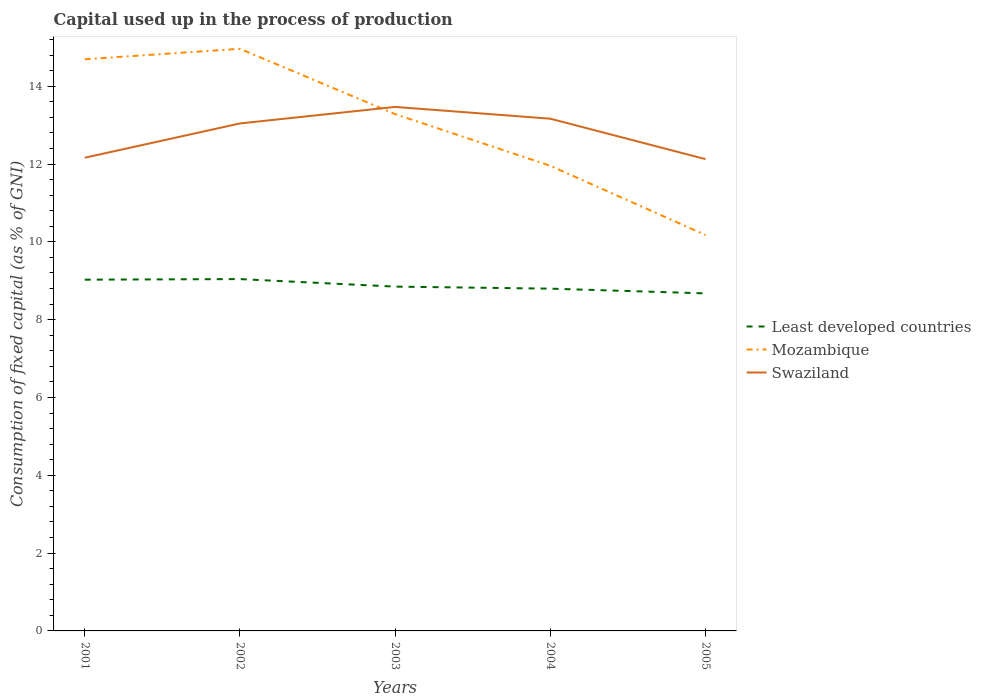Is the number of lines equal to the number of legend labels?
Make the answer very short. Yes. Across all years, what is the maximum capital used up in the process of production in Swaziland?
Keep it short and to the point. 12.13. What is the total capital used up in the process of production in Mozambique in the graph?
Make the answer very short. 1.33. What is the difference between the highest and the second highest capital used up in the process of production in Swaziland?
Offer a terse response. 1.34. What is the difference between the highest and the lowest capital used up in the process of production in Mozambique?
Ensure brevity in your answer.  3. How many lines are there?
Offer a very short reply. 3. How many years are there in the graph?
Your response must be concise. 5. What is the difference between two consecutive major ticks on the Y-axis?
Keep it short and to the point. 2. Are the values on the major ticks of Y-axis written in scientific E-notation?
Your response must be concise. No. Does the graph contain any zero values?
Keep it short and to the point. No. How many legend labels are there?
Give a very brief answer. 3. What is the title of the graph?
Keep it short and to the point. Capital used up in the process of production. What is the label or title of the X-axis?
Offer a very short reply. Years. What is the label or title of the Y-axis?
Offer a terse response. Consumption of fixed capital (as % of GNI). What is the Consumption of fixed capital (as % of GNI) of Least developed countries in 2001?
Your answer should be compact. 9.03. What is the Consumption of fixed capital (as % of GNI) in Mozambique in 2001?
Make the answer very short. 14.69. What is the Consumption of fixed capital (as % of GNI) in Swaziland in 2001?
Keep it short and to the point. 12.16. What is the Consumption of fixed capital (as % of GNI) in Least developed countries in 2002?
Give a very brief answer. 9.04. What is the Consumption of fixed capital (as % of GNI) in Mozambique in 2002?
Make the answer very short. 14.96. What is the Consumption of fixed capital (as % of GNI) in Swaziland in 2002?
Offer a terse response. 13.04. What is the Consumption of fixed capital (as % of GNI) of Least developed countries in 2003?
Offer a terse response. 8.85. What is the Consumption of fixed capital (as % of GNI) of Mozambique in 2003?
Ensure brevity in your answer.  13.28. What is the Consumption of fixed capital (as % of GNI) of Swaziland in 2003?
Your answer should be very brief. 13.47. What is the Consumption of fixed capital (as % of GNI) in Least developed countries in 2004?
Keep it short and to the point. 8.8. What is the Consumption of fixed capital (as % of GNI) of Mozambique in 2004?
Make the answer very short. 11.95. What is the Consumption of fixed capital (as % of GNI) of Swaziland in 2004?
Your answer should be compact. 13.16. What is the Consumption of fixed capital (as % of GNI) of Least developed countries in 2005?
Offer a very short reply. 8.68. What is the Consumption of fixed capital (as % of GNI) in Mozambique in 2005?
Offer a very short reply. 10.17. What is the Consumption of fixed capital (as % of GNI) in Swaziland in 2005?
Provide a succinct answer. 12.13. Across all years, what is the maximum Consumption of fixed capital (as % of GNI) in Least developed countries?
Make the answer very short. 9.04. Across all years, what is the maximum Consumption of fixed capital (as % of GNI) of Mozambique?
Provide a succinct answer. 14.96. Across all years, what is the maximum Consumption of fixed capital (as % of GNI) in Swaziland?
Offer a very short reply. 13.47. Across all years, what is the minimum Consumption of fixed capital (as % of GNI) in Least developed countries?
Keep it short and to the point. 8.68. Across all years, what is the minimum Consumption of fixed capital (as % of GNI) of Mozambique?
Offer a terse response. 10.17. Across all years, what is the minimum Consumption of fixed capital (as % of GNI) in Swaziland?
Keep it short and to the point. 12.13. What is the total Consumption of fixed capital (as % of GNI) of Least developed countries in the graph?
Provide a short and direct response. 44.39. What is the total Consumption of fixed capital (as % of GNI) in Mozambique in the graph?
Offer a very short reply. 65.06. What is the total Consumption of fixed capital (as % of GNI) of Swaziland in the graph?
Your answer should be compact. 63.96. What is the difference between the Consumption of fixed capital (as % of GNI) of Least developed countries in 2001 and that in 2002?
Provide a succinct answer. -0.02. What is the difference between the Consumption of fixed capital (as % of GNI) in Mozambique in 2001 and that in 2002?
Keep it short and to the point. -0.27. What is the difference between the Consumption of fixed capital (as % of GNI) in Swaziland in 2001 and that in 2002?
Offer a terse response. -0.88. What is the difference between the Consumption of fixed capital (as % of GNI) in Least developed countries in 2001 and that in 2003?
Give a very brief answer. 0.18. What is the difference between the Consumption of fixed capital (as % of GNI) in Mozambique in 2001 and that in 2003?
Offer a terse response. 1.41. What is the difference between the Consumption of fixed capital (as % of GNI) of Swaziland in 2001 and that in 2003?
Keep it short and to the point. -1.31. What is the difference between the Consumption of fixed capital (as % of GNI) of Least developed countries in 2001 and that in 2004?
Keep it short and to the point. 0.23. What is the difference between the Consumption of fixed capital (as % of GNI) in Mozambique in 2001 and that in 2004?
Keep it short and to the point. 2.74. What is the difference between the Consumption of fixed capital (as % of GNI) in Swaziland in 2001 and that in 2004?
Your response must be concise. -1. What is the difference between the Consumption of fixed capital (as % of GNI) in Least developed countries in 2001 and that in 2005?
Make the answer very short. 0.35. What is the difference between the Consumption of fixed capital (as % of GNI) of Mozambique in 2001 and that in 2005?
Provide a succinct answer. 4.52. What is the difference between the Consumption of fixed capital (as % of GNI) in Swaziland in 2001 and that in 2005?
Keep it short and to the point. 0.04. What is the difference between the Consumption of fixed capital (as % of GNI) of Least developed countries in 2002 and that in 2003?
Provide a short and direct response. 0.19. What is the difference between the Consumption of fixed capital (as % of GNI) of Mozambique in 2002 and that in 2003?
Ensure brevity in your answer.  1.68. What is the difference between the Consumption of fixed capital (as % of GNI) of Swaziland in 2002 and that in 2003?
Your answer should be compact. -0.42. What is the difference between the Consumption of fixed capital (as % of GNI) in Least developed countries in 2002 and that in 2004?
Provide a short and direct response. 0.25. What is the difference between the Consumption of fixed capital (as % of GNI) in Mozambique in 2002 and that in 2004?
Provide a succinct answer. 3.01. What is the difference between the Consumption of fixed capital (as % of GNI) of Swaziland in 2002 and that in 2004?
Offer a very short reply. -0.12. What is the difference between the Consumption of fixed capital (as % of GNI) of Least developed countries in 2002 and that in 2005?
Give a very brief answer. 0.37. What is the difference between the Consumption of fixed capital (as % of GNI) of Mozambique in 2002 and that in 2005?
Offer a very short reply. 4.79. What is the difference between the Consumption of fixed capital (as % of GNI) in Swaziland in 2002 and that in 2005?
Keep it short and to the point. 0.92. What is the difference between the Consumption of fixed capital (as % of GNI) of Least developed countries in 2003 and that in 2004?
Give a very brief answer. 0.05. What is the difference between the Consumption of fixed capital (as % of GNI) of Mozambique in 2003 and that in 2004?
Your answer should be very brief. 1.33. What is the difference between the Consumption of fixed capital (as % of GNI) of Swaziland in 2003 and that in 2004?
Your answer should be compact. 0.3. What is the difference between the Consumption of fixed capital (as % of GNI) in Least developed countries in 2003 and that in 2005?
Offer a very short reply. 0.17. What is the difference between the Consumption of fixed capital (as % of GNI) in Mozambique in 2003 and that in 2005?
Your response must be concise. 3.11. What is the difference between the Consumption of fixed capital (as % of GNI) of Swaziland in 2003 and that in 2005?
Make the answer very short. 1.34. What is the difference between the Consumption of fixed capital (as % of GNI) in Least developed countries in 2004 and that in 2005?
Keep it short and to the point. 0.12. What is the difference between the Consumption of fixed capital (as % of GNI) in Mozambique in 2004 and that in 2005?
Provide a short and direct response. 1.78. What is the difference between the Consumption of fixed capital (as % of GNI) of Swaziland in 2004 and that in 2005?
Offer a very short reply. 1.04. What is the difference between the Consumption of fixed capital (as % of GNI) in Least developed countries in 2001 and the Consumption of fixed capital (as % of GNI) in Mozambique in 2002?
Offer a terse response. -5.93. What is the difference between the Consumption of fixed capital (as % of GNI) of Least developed countries in 2001 and the Consumption of fixed capital (as % of GNI) of Swaziland in 2002?
Give a very brief answer. -4.01. What is the difference between the Consumption of fixed capital (as % of GNI) in Mozambique in 2001 and the Consumption of fixed capital (as % of GNI) in Swaziland in 2002?
Your response must be concise. 1.65. What is the difference between the Consumption of fixed capital (as % of GNI) of Least developed countries in 2001 and the Consumption of fixed capital (as % of GNI) of Mozambique in 2003?
Keep it short and to the point. -4.25. What is the difference between the Consumption of fixed capital (as % of GNI) of Least developed countries in 2001 and the Consumption of fixed capital (as % of GNI) of Swaziland in 2003?
Offer a very short reply. -4.44. What is the difference between the Consumption of fixed capital (as % of GNI) in Mozambique in 2001 and the Consumption of fixed capital (as % of GNI) in Swaziland in 2003?
Give a very brief answer. 1.23. What is the difference between the Consumption of fixed capital (as % of GNI) in Least developed countries in 2001 and the Consumption of fixed capital (as % of GNI) in Mozambique in 2004?
Keep it short and to the point. -2.93. What is the difference between the Consumption of fixed capital (as % of GNI) in Least developed countries in 2001 and the Consumption of fixed capital (as % of GNI) in Swaziland in 2004?
Offer a very short reply. -4.14. What is the difference between the Consumption of fixed capital (as % of GNI) of Mozambique in 2001 and the Consumption of fixed capital (as % of GNI) of Swaziland in 2004?
Offer a terse response. 1.53. What is the difference between the Consumption of fixed capital (as % of GNI) in Least developed countries in 2001 and the Consumption of fixed capital (as % of GNI) in Mozambique in 2005?
Provide a succinct answer. -1.15. What is the difference between the Consumption of fixed capital (as % of GNI) of Least developed countries in 2001 and the Consumption of fixed capital (as % of GNI) of Swaziland in 2005?
Provide a succinct answer. -3.1. What is the difference between the Consumption of fixed capital (as % of GNI) of Mozambique in 2001 and the Consumption of fixed capital (as % of GNI) of Swaziland in 2005?
Give a very brief answer. 2.57. What is the difference between the Consumption of fixed capital (as % of GNI) of Least developed countries in 2002 and the Consumption of fixed capital (as % of GNI) of Mozambique in 2003?
Make the answer very short. -4.24. What is the difference between the Consumption of fixed capital (as % of GNI) of Least developed countries in 2002 and the Consumption of fixed capital (as % of GNI) of Swaziland in 2003?
Offer a terse response. -4.42. What is the difference between the Consumption of fixed capital (as % of GNI) in Mozambique in 2002 and the Consumption of fixed capital (as % of GNI) in Swaziland in 2003?
Make the answer very short. 1.49. What is the difference between the Consumption of fixed capital (as % of GNI) of Least developed countries in 2002 and the Consumption of fixed capital (as % of GNI) of Mozambique in 2004?
Your answer should be compact. -2.91. What is the difference between the Consumption of fixed capital (as % of GNI) of Least developed countries in 2002 and the Consumption of fixed capital (as % of GNI) of Swaziland in 2004?
Make the answer very short. -4.12. What is the difference between the Consumption of fixed capital (as % of GNI) of Mozambique in 2002 and the Consumption of fixed capital (as % of GNI) of Swaziland in 2004?
Make the answer very short. 1.8. What is the difference between the Consumption of fixed capital (as % of GNI) in Least developed countries in 2002 and the Consumption of fixed capital (as % of GNI) in Mozambique in 2005?
Offer a terse response. -1.13. What is the difference between the Consumption of fixed capital (as % of GNI) in Least developed countries in 2002 and the Consumption of fixed capital (as % of GNI) in Swaziland in 2005?
Keep it short and to the point. -3.08. What is the difference between the Consumption of fixed capital (as % of GNI) of Mozambique in 2002 and the Consumption of fixed capital (as % of GNI) of Swaziland in 2005?
Keep it short and to the point. 2.84. What is the difference between the Consumption of fixed capital (as % of GNI) in Least developed countries in 2003 and the Consumption of fixed capital (as % of GNI) in Mozambique in 2004?
Provide a succinct answer. -3.11. What is the difference between the Consumption of fixed capital (as % of GNI) of Least developed countries in 2003 and the Consumption of fixed capital (as % of GNI) of Swaziland in 2004?
Offer a very short reply. -4.32. What is the difference between the Consumption of fixed capital (as % of GNI) in Mozambique in 2003 and the Consumption of fixed capital (as % of GNI) in Swaziland in 2004?
Keep it short and to the point. 0.12. What is the difference between the Consumption of fixed capital (as % of GNI) of Least developed countries in 2003 and the Consumption of fixed capital (as % of GNI) of Mozambique in 2005?
Offer a very short reply. -1.33. What is the difference between the Consumption of fixed capital (as % of GNI) of Least developed countries in 2003 and the Consumption of fixed capital (as % of GNI) of Swaziland in 2005?
Your response must be concise. -3.28. What is the difference between the Consumption of fixed capital (as % of GNI) in Mozambique in 2003 and the Consumption of fixed capital (as % of GNI) in Swaziland in 2005?
Keep it short and to the point. 1.16. What is the difference between the Consumption of fixed capital (as % of GNI) of Least developed countries in 2004 and the Consumption of fixed capital (as % of GNI) of Mozambique in 2005?
Keep it short and to the point. -1.38. What is the difference between the Consumption of fixed capital (as % of GNI) of Least developed countries in 2004 and the Consumption of fixed capital (as % of GNI) of Swaziland in 2005?
Your answer should be very brief. -3.33. What is the difference between the Consumption of fixed capital (as % of GNI) of Mozambique in 2004 and the Consumption of fixed capital (as % of GNI) of Swaziland in 2005?
Provide a short and direct response. -0.17. What is the average Consumption of fixed capital (as % of GNI) of Least developed countries per year?
Your answer should be very brief. 8.88. What is the average Consumption of fixed capital (as % of GNI) in Mozambique per year?
Your answer should be compact. 13.01. What is the average Consumption of fixed capital (as % of GNI) in Swaziland per year?
Your answer should be compact. 12.79. In the year 2001, what is the difference between the Consumption of fixed capital (as % of GNI) of Least developed countries and Consumption of fixed capital (as % of GNI) of Mozambique?
Provide a succinct answer. -5.66. In the year 2001, what is the difference between the Consumption of fixed capital (as % of GNI) of Least developed countries and Consumption of fixed capital (as % of GNI) of Swaziland?
Provide a short and direct response. -3.13. In the year 2001, what is the difference between the Consumption of fixed capital (as % of GNI) of Mozambique and Consumption of fixed capital (as % of GNI) of Swaziland?
Your answer should be very brief. 2.53. In the year 2002, what is the difference between the Consumption of fixed capital (as % of GNI) in Least developed countries and Consumption of fixed capital (as % of GNI) in Mozambique?
Provide a succinct answer. -5.92. In the year 2002, what is the difference between the Consumption of fixed capital (as % of GNI) in Least developed countries and Consumption of fixed capital (as % of GNI) in Swaziland?
Offer a very short reply. -4. In the year 2002, what is the difference between the Consumption of fixed capital (as % of GNI) of Mozambique and Consumption of fixed capital (as % of GNI) of Swaziland?
Provide a succinct answer. 1.92. In the year 2003, what is the difference between the Consumption of fixed capital (as % of GNI) in Least developed countries and Consumption of fixed capital (as % of GNI) in Mozambique?
Your answer should be very brief. -4.43. In the year 2003, what is the difference between the Consumption of fixed capital (as % of GNI) in Least developed countries and Consumption of fixed capital (as % of GNI) in Swaziland?
Ensure brevity in your answer.  -4.62. In the year 2003, what is the difference between the Consumption of fixed capital (as % of GNI) in Mozambique and Consumption of fixed capital (as % of GNI) in Swaziland?
Offer a terse response. -0.19. In the year 2004, what is the difference between the Consumption of fixed capital (as % of GNI) in Least developed countries and Consumption of fixed capital (as % of GNI) in Mozambique?
Your answer should be compact. -3.16. In the year 2004, what is the difference between the Consumption of fixed capital (as % of GNI) of Least developed countries and Consumption of fixed capital (as % of GNI) of Swaziland?
Give a very brief answer. -4.37. In the year 2004, what is the difference between the Consumption of fixed capital (as % of GNI) of Mozambique and Consumption of fixed capital (as % of GNI) of Swaziland?
Offer a terse response. -1.21. In the year 2005, what is the difference between the Consumption of fixed capital (as % of GNI) in Least developed countries and Consumption of fixed capital (as % of GNI) in Mozambique?
Make the answer very short. -1.5. In the year 2005, what is the difference between the Consumption of fixed capital (as % of GNI) of Least developed countries and Consumption of fixed capital (as % of GNI) of Swaziland?
Your answer should be compact. -3.45. In the year 2005, what is the difference between the Consumption of fixed capital (as % of GNI) of Mozambique and Consumption of fixed capital (as % of GNI) of Swaziland?
Your response must be concise. -1.95. What is the ratio of the Consumption of fixed capital (as % of GNI) in Mozambique in 2001 to that in 2002?
Provide a succinct answer. 0.98. What is the ratio of the Consumption of fixed capital (as % of GNI) of Swaziland in 2001 to that in 2002?
Keep it short and to the point. 0.93. What is the ratio of the Consumption of fixed capital (as % of GNI) in Least developed countries in 2001 to that in 2003?
Your response must be concise. 1.02. What is the ratio of the Consumption of fixed capital (as % of GNI) in Mozambique in 2001 to that in 2003?
Keep it short and to the point. 1.11. What is the ratio of the Consumption of fixed capital (as % of GNI) in Swaziland in 2001 to that in 2003?
Offer a terse response. 0.9. What is the ratio of the Consumption of fixed capital (as % of GNI) of Least developed countries in 2001 to that in 2004?
Your answer should be very brief. 1.03. What is the ratio of the Consumption of fixed capital (as % of GNI) in Mozambique in 2001 to that in 2004?
Offer a very short reply. 1.23. What is the ratio of the Consumption of fixed capital (as % of GNI) of Swaziland in 2001 to that in 2004?
Provide a short and direct response. 0.92. What is the ratio of the Consumption of fixed capital (as % of GNI) in Least developed countries in 2001 to that in 2005?
Ensure brevity in your answer.  1.04. What is the ratio of the Consumption of fixed capital (as % of GNI) of Mozambique in 2001 to that in 2005?
Offer a terse response. 1.44. What is the ratio of the Consumption of fixed capital (as % of GNI) in Swaziland in 2001 to that in 2005?
Provide a short and direct response. 1. What is the ratio of the Consumption of fixed capital (as % of GNI) of Least developed countries in 2002 to that in 2003?
Your response must be concise. 1.02. What is the ratio of the Consumption of fixed capital (as % of GNI) in Mozambique in 2002 to that in 2003?
Ensure brevity in your answer.  1.13. What is the ratio of the Consumption of fixed capital (as % of GNI) of Swaziland in 2002 to that in 2003?
Your response must be concise. 0.97. What is the ratio of the Consumption of fixed capital (as % of GNI) of Least developed countries in 2002 to that in 2004?
Offer a terse response. 1.03. What is the ratio of the Consumption of fixed capital (as % of GNI) in Mozambique in 2002 to that in 2004?
Your response must be concise. 1.25. What is the ratio of the Consumption of fixed capital (as % of GNI) of Swaziland in 2002 to that in 2004?
Ensure brevity in your answer.  0.99. What is the ratio of the Consumption of fixed capital (as % of GNI) of Least developed countries in 2002 to that in 2005?
Offer a very short reply. 1.04. What is the ratio of the Consumption of fixed capital (as % of GNI) of Mozambique in 2002 to that in 2005?
Your answer should be compact. 1.47. What is the ratio of the Consumption of fixed capital (as % of GNI) in Swaziland in 2002 to that in 2005?
Your response must be concise. 1.08. What is the ratio of the Consumption of fixed capital (as % of GNI) of Least developed countries in 2003 to that in 2004?
Keep it short and to the point. 1.01. What is the ratio of the Consumption of fixed capital (as % of GNI) in Swaziland in 2003 to that in 2004?
Give a very brief answer. 1.02. What is the ratio of the Consumption of fixed capital (as % of GNI) in Least developed countries in 2003 to that in 2005?
Your response must be concise. 1.02. What is the ratio of the Consumption of fixed capital (as % of GNI) of Mozambique in 2003 to that in 2005?
Offer a terse response. 1.31. What is the ratio of the Consumption of fixed capital (as % of GNI) in Swaziland in 2003 to that in 2005?
Your response must be concise. 1.11. What is the ratio of the Consumption of fixed capital (as % of GNI) in Least developed countries in 2004 to that in 2005?
Provide a succinct answer. 1.01. What is the ratio of the Consumption of fixed capital (as % of GNI) of Mozambique in 2004 to that in 2005?
Your answer should be compact. 1.17. What is the ratio of the Consumption of fixed capital (as % of GNI) of Swaziland in 2004 to that in 2005?
Your response must be concise. 1.09. What is the difference between the highest and the second highest Consumption of fixed capital (as % of GNI) of Least developed countries?
Offer a terse response. 0.02. What is the difference between the highest and the second highest Consumption of fixed capital (as % of GNI) of Mozambique?
Provide a short and direct response. 0.27. What is the difference between the highest and the second highest Consumption of fixed capital (as % of GNI) of Swaziland?
Provide a succinct answer. 0.3. What is the difference between the highest and the lowest Consumption of fixed capital (as % of GNI) of Least developed countries?
Your answer should be very brief. 0.37. What is the difference between the highest and the lowest Consumption of fixed capital (as % of GNI) in Mozambique?
Your response must be concise. 4.79. What is the difference between the highest and the lowest Consumption of fixed capital (as % of GNI) of Swaziland?
Ensure brevity in your answer.  1.34. 